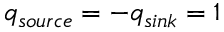<formula> <loc_0><loc_0><loc_500><loc_500>q _ { s o u r c e } = - q _ { \sin k } = 1</formula> 